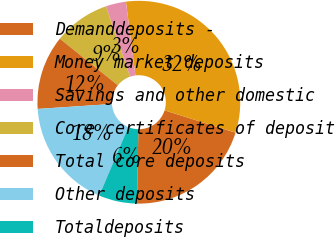<chart> <loc_0><loc_0><loc_500><loc_500><pie_chart><fcel>Demanddeposits -<fcel>Money market deposits<fcel>Savings and other domestic<fcel>Core certificates of deposit<fcel>Total core deposits<fcel>Other deposits<fcel>Totaldeposits<nl><fcel>20.43%<fcel>31.89%<fcel>3.23%<fcel>8.96%<fcel>11.83%<fcel>17.56%<fcel>6.1%<nl></chart> 